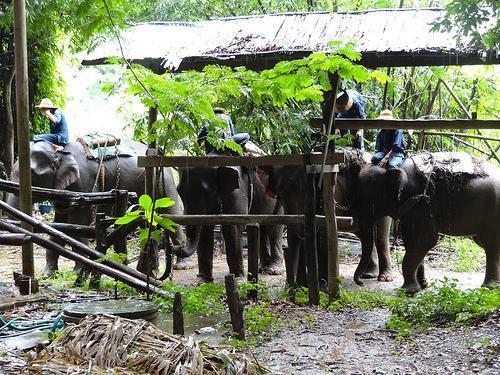How many elephants can be seen?
Give a very brief answer. 4. 